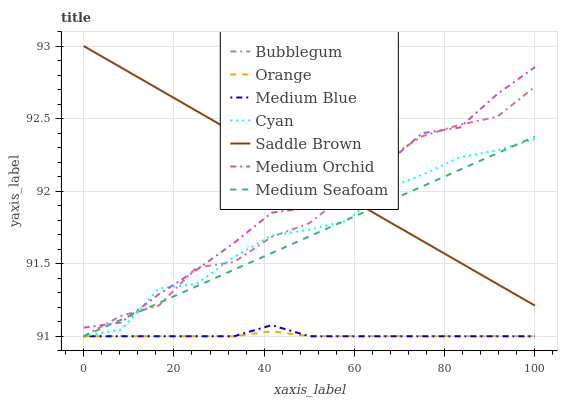Does Orange have the minimum area under the curve?
Answer yes or no. Yes. Does Saddle Brown have the maximum area under the curve?
Answer yes or no. Yes. Does Medium Blue have the minimum area under the curve?
Answer yes or no. No. Does Medium Blue have the maximum area under the curve?
Answer yes or no. No. Is Medium Seafoam the smoothest?
Answer yes or no. Yes. Is Cyan the roughest?
Answer yes or no. Yes. Is Medium Blue the smoothest?
Answer yes or no. No. Is Medium Blue the roughest?
Answer yes or no. No. Does Medium Blue have the lowest value?
Answer yes or no. Yes. Does Saddle Brown have the lowest value?
Answer yes or no. No. Does Saddle Brown have the highest value?
Answer yes or no. Yes. Does Medium Blue have the highest value?
Answer yes or no. No. Is Orange less than Saddle Brown?
Answer yes or no. Yes. Is Saddle Brown greater than Orange?
Answer yes or no. Yes. Does Medium Blue intersect Bubblegum?
Answer yes or no. Yes. Is Medium Blue less than Bubblegum?
Answer yes or no. No. Is Medium Blue greater than Bubblegum?
Answer yes or no. No. Does Orange intersect Saddle Brown?
Answer yes or no. No. 